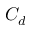<formula> <loc_0><loc_0><loc_500><loc_500>C _ { d }</formula> 